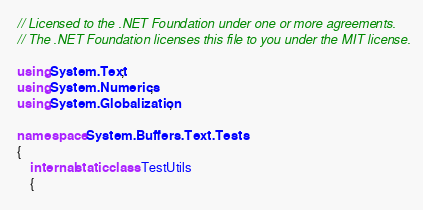<code> <loc_0><loc_0><loc_500><loc_500><_C#_>// Licensed to the .NET Foundation under one or more agreements.
// The .NET Foundation licenses this file to you under the MIT license.

using System.Text;
using System.Numerics;
using System.Globalization;

namespace System.Buffers.Text.Tests
{
    internal static class TestUtils
    {</code> 